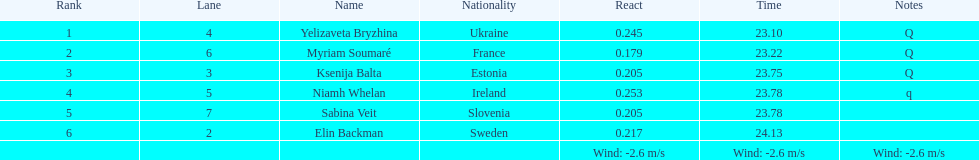What number of last names start with "b"? 3. 